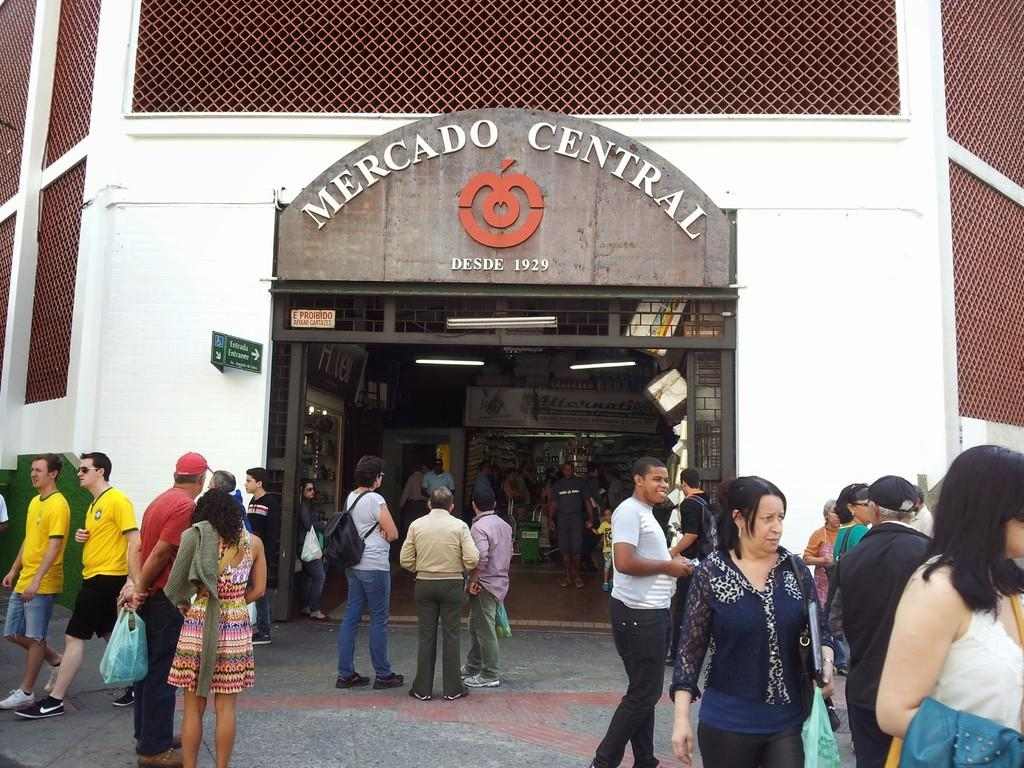<image>
Describe the image concisely. An entrance to the building that says Mercado Central. 